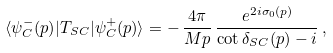Convert formula to latex. <formula><loc_0><loc_0><loc_500><loc_500>\langle \psi ^ { - } _ { C } ( p ) | T _ { S C } | \psi ^ { + } _ { C } ( p ) \rangle = - \, \frac { 4 \pi } { M p } \, \frac { e ^ { 2 i \sigma _ { 0 } ( p ) } } { \cot \delta _ { S C } ( p ) - i } \, ,</formula> 